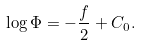<formula> <loc_0><loc_0><loc_500><loc_500>\log \Phi = - \frac { f } 2 + C _ { 0 } .</formula> 